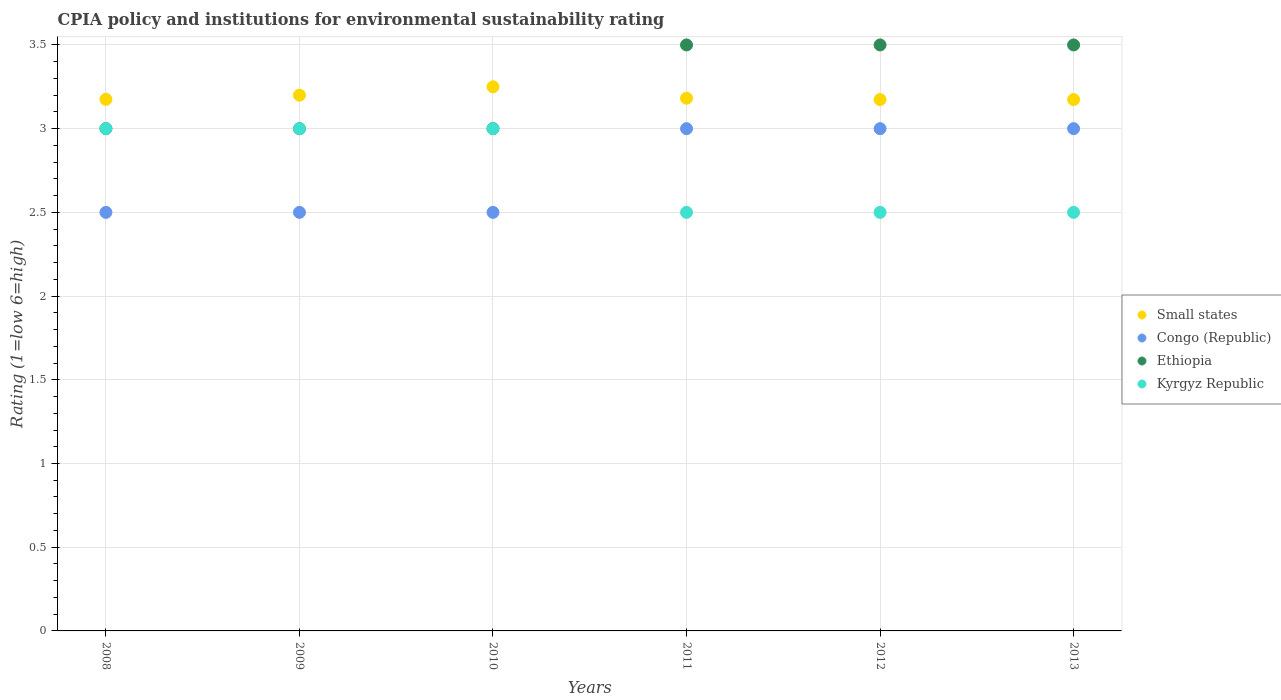Across all years, what is the minimum CPIA rating in Small states?
Your answer should be very brief. 3.17. What is the total CPIA rating in Congo (Republic) in the graph?
Offer a very short reply. 16.5. What is the difference between the CPIA rating in Small states in 2009 and that in 2011?
Offer a very short reply. 0.02. What is the difference between the CPIA rating in Small states in 2010 and the CPIA rating in Congo (Republic) in 2008?
Keep it short and to the point. 0.75. What is the average CPIA rating in Ethiopia per year?
Your answer should be compact. 3.25. In how many years, is the CPIA rating in Ethiopia greater than 2.5?
Make the answer very short. 6. Is the CPIA rating in Ethiopia in 2009 less than that in 2013?
Offer a very short reply. Yes. Is it the case that in every year, the sum of the CPIA rating in Small states and CPIA rating in Kyrgyz Republic  is greater than the sum of CPIA rating in Ethiopia and CPIA rating in Congo (Republic)?
Your answer should be very brief. No. Is it the case that in every year, the sum of the CPIA rating in Small states and CPIA rating in Congo (Republic)  is greater than the CPIA rating in Ethiopia?
Your answer should be very brief. Yes. Does the CPIA rating in Kyrgyz Republic monotonically increase over the years?
Your answer should be compact. No. Is the CPIA rating in Ethiopia strictly greater than the CPIA rating in Small states over the years?
Offer a terse response. No. How many dotlines are there?
Offer a very short reply. 4. Are the values on the major ticks of Y-axis written in scientific E-notation?
Your answer should be very brief. No. Does the graph contain any zero values?
Make the answer very short. No. How many legend labels are there?
Give a very brief answer. 4. How are the legend labels stacked?
Give a very brief answer. Vertical. What is the title of the graph?
Your response must be concise. CPIA policy and institutions for environmental sustainability rating. What is the label or title of the Y-axis?
Your response must be concise. Rating (1=low 6=high). What is the Rating (1=low 6=high) of Small states in 2008?
Your answer should be compact. 3.17. What is the Rating (1=low 6=high) in Congo (Republic) in 2008?
Make the answer very short. 2.5. What is the Rating (1=low 6=high) in Kyrgyz Republic in 2008?
Give a very brief answer. 3. What is the Rating (1=low 6=high) of Small states in 2009?
Your answer should be very brief. 3.2. What is the Rating (1=low 6=high) in Congo (Republic) in 2009?
Your answer should be very brief. 2.5. What is the Rating (1=low 6=high) in Ethiopia in 2009?
Keep it short and to the point. 3. What is the Rating (1=low 6=high) of Congo (Republic) in 2010?
Offer a terse response. 2.5. What is the Rating (1=low 6=high) in Small states in 2011?
Your response must be concise. 3.18. What is the Rating (1=low 6=high) in Ethiopia in 2011?
Your answer should be compact. 3.5. What is the Rating (1=low 6=high) in Small states in 2012?
Keep it short and to the point. 3.17. What is the Rating (1=low 6=high) in Small states in 2013?
Provide a short and direct response. 3.17. What is the Rating (1=low 6=high) of Congo (Republic) in 2013?
Ensure brevity in your answer.  3. What is the Rating (1=low 6=high) in Ethiopia in 2013?
Give a very brief answer. 3.5. What is the Rating (1=low 6=high) of Kyrgyz Republic in 2013?
Your answer should be compact. 2.5. Across all years, what is the maximum Rating (1=low 6=high) in Small states?
Offer a very short reply. 3.25. Across all years, what is the maximum Rating (1=low 6=high) in Congo (Republic)?
Offer a terse response. 3. Across all years, what is the maximum Rating (1=low 6=high) in Ethiopia?
Keep it short and to the point. 3.5. Across all years, what is the minimum Rating (1=low 6=high) of Small states?
Keep it short and to the point. 3.17. Across all years, what is the minimum Rating (1=low 6=high) of Congo (Republic)?
Ensure brevity in your answer.  2.5. Across all years, what is the minimum Rating (1=low 6=high) of Ethiopia?
Give a very brief answer. 3. Across all years, what is the minimum Rating (1=low 6=high) in Kyrgyz Republic?
Ensure brevity in your answer.  2.5. What is the total Rating (1=low 6=high) in Small states in the graph?
Offer a very short reply. 19.15. What is the difference between the Rating (1=low 6=high) in Small states in 2008 and that in 2009?
Keep it short and to the point. -0.03. What is the difference between the Rating (1=low 6=high) of Ethiopia in 2008 and that in 2009?
Your answer should be very brief. 0. What is the difference between the Rating (1=low 6=high) of Kyrgyz Republic in 2008 and that in 2009?
Give a very brief answer. 0. What is the difference between the Rating (1=low 6=high) of Small states in 2008 and that in 2010?
Provide a short and direct response. -0.07. What is the difference between the Rating (1=low 6=high) in Congo (Republic) in 2008 and that in 2010?
Your answer should be very brief. 0. What is the difference between the Rating (1=low 6=high) in Ethiopia in 2008 and that in 2010?
Provide a succinct answer. 0. What is the difference between the Rating (1=low 6=high) of Kyrgyz Republic in 2008 and that in 2010?
Make the answer very short. 0. What is the difference between the Rating (1=low 6=high) of Small states in 2008 and that in 2011?
Make the answer very short. -0.01. What is the difference between the Rating (1=low 6=high) of Kyrgyz Republic in 2008 and that in 2011?
Offer a very short reply. 0.5. What is the difference between the Rating (1=low 6=high) in Small states in 2008 and that in 2012?
Provide a succinct answer. 0. What is the difference between the Rating (1=low 6=high) in Congo (Republic) in 2008 and that in 2012?
Offer a very short reply. -0.5. What is the difference between the Rating (1=low 6=high) in Ethiopia in 2008 and that in 2012?
Provide a succinct answer. -0.5. What is the difference between the Rating (1=low 6=high) in Small states in 2008 and that in 2013?
Provide a succinct answer. 0. What is the difference between the Rating (1=low 6=high) of Kyrgyz Republic in 2009 and that in 2010?
Offer a very short reply. 0. What is the difference between the Rating (1=low 6=high) in Small states in 2009 and that in 2011?
Your answer should be very brief. 0.02. What is the difference between the Rating (1=low 6=high) in Ethiopia in 2009 and that in 2011?
Your response must be concise. -0.5. What is the difference between the Rating (1=low 6=high) in Kyrgyz Republic in 2009 and that in 2011?
Provide a short and direct response. 0.5. What is the difference between the Rating (1=low 6=high) in Small states in 2009 and that in 2012?
Provide a short and direct response. 0.03. What is the difference between the Rating (1=low 6=high) of Congo (Republic) in 2009 and that in 2012?
Your answer should be compact. -0.5. What is the difference between the Rating (1=low 6=high) in Kyrgyz Republic in 2009 and that in 2012?
Your answer should be compact. 0.5. What is the difference between the Rating (1=low 6=high) of Small states in 2009 and that in 2013?
Your response must be concise. 0.03. What is the difference between the Rating (1=low 6=high) of Congo (Republic) in 2009 and that in 2013?
Your response must be concise. -0.5. What is the difference between the Rating (1=low 6=high) of Kyrgyz Republic in 2009 and that in 2013?
Offer a very short reply. 0.5. What is the difference between the Rating (1=low 6=high) of Small states in 2010 and that in 2011?
Give a very brief answer. 0.07. What is the difference between the Rating (1=low 6=high) in Ethiopia in 2010 and that in 2011?
Offer a very short reply. -0.5. What is the difference between the Rating (1=low 6=high) in Kyrgyz Republic in 2010 and that in 2011?
Ensure brevity in your answer.  0.5. What is the difference between the Rating (1=low 6=high) of Small states in 2010 and that in 2012?
Make the answer very short. 0.08. What is the difference between the Rating (1=low 6=high) of Ethiopia in 2010 and that in 2012?
Offer a terse response. -0.5. What is the difference between the Rating (1=low 6=high) in Kyrgyz Republic in 2010 and that in 2012?
Offer a terse response. 0.5. What is the difference between the Rating (1=low 6=high) of Small states in 2010 and that in 2013?
Your response must be concise. 0.08. What is the difference between the Rating (1=low 6=high) in Congo (Republic) in 2010 and that in 2013?
Keep it short and to the point. -0.5. What is the difference between the Rating (1=low 6=high) of Ethiopia in 2010 and that in 2013?
Provide a succinct answer. -0.5. What is the difference between the Rating (1=low 6=high) in Small states in 2011 and that in 2012?
Offer a very short reply. 0.01. What is the difference between the Rating (1=low 6=high) of Small states in 2011 and that in 2013?
Make the answer very short. 0.01. What is the difference between the Rating (1=low 6=high) of Ethiopia in 2011 and that in 2013?
Your response must be concise. 0. What is the difference between the Rating (1=low 6=high) of Small states in 2012 and that in 2013?
Your response must be concise. 0. What is the difference between the Rating (1=low 6=high) of Kyrgyz Republic in 2012 and that in 2013?
Your answer should be compact. 0. What is the difference between the Rating (1=low 6=high) in Small states in 2008 and the Rating (1=low 6=high) in Congo (Republic) in 2009?
Provide a succinct answer. 0.68. What is the difference between the Rating (1=low 6=high) in Small states in 2008 and the Rating (1=low 6=high) in Ethiopia in 2009?
Your response must be concise. 0.17. What is the difference between the Rating (1=low 6=high) in Small states in 2008 and the Rating (1=low 6=high) in Kyrgyz Republic in 2009?
Ensure brevity in your answer.  0.17. What is the difference between the Rating (1=low 6=high) in Congo (Republic) in 2008 and the Rating (1=low 6=high) in Ethiopia in 2009?
Your answer should be very brief. -0.5. What is the difference between the Rating (1=low 6=high) of Ethiopia in 2008 and the Rating (1=low 6=high) of Kyrgyz Republic in 2009?
Your response must be concise. 0. What is the difference between the Rating (1=low 6=high) in Small states in 2008 and the Rating (1=low 6=high) in Congo (Republic) in 2010?
Offer a very short reply. 0.68. What is the difference between the Rating (1=low 6=high) in Small states in 2008 and the Rating (1=low 6=high) in Ethiopia in 2010?
Make the answer very short. 0.17. What is the difference between the Rating (1=low 6=high) of Small states in 2008 and the Rating (1=low 6=high) of Kyrgyz Republic in 2010?
Provide a short and direct response. 0.17. What is the difference between the Rating (1=low 6=high) of Congo (Republic) in 2008 and the Rating (1=low 6=high) of Kyrgyz Republic in 2010?
Offer a very short reply. -0.5. What is the difference between the Rating (1=low 6=high) of Ethiopia in 2008 and the Rating (1=low 6=high) of Kyrgyz Republic in 2010?
Your answer should be very brief. 0. What is the difference between the Rating (1=low 6=high) of Small states in 2008 and the Rating (1=low 6=high) of Congo (Republic) in 2011?
Provide a succinct answer. 0.17. What is the difference between the Rating (1=low 6=high) of Small states in 2008 and the Rating (1=low 6=high) of Ethiopia in 2011?
Give a very brief answer. -0.33. What is the difference between the Rating (1=low 6=high) in Small states in 2008 and the Rating (1=low 6=high) in Kyrgyz Republic in 2011?
Give a very brief answer. 0.68. What is the difference between the Rating (1=low 6=high) of Ethiopia in 2008 and the Rating (1=low 6=high) of Kyrgyz Republic in 2011?
Keep it short and to the point. 0.5. What is the difference between the Rating (1=low 6=high) in Small states in 2008 and the Rating (1=low 6=high) in Congo (Republic) in 2012?
Your answer should be very brief. 0.17. What is the difference between the Rating (1=low 6=high) of Small states in 2008 and the Rating (1=low 6=high) of Ethiopia in 2012?
Your response must be concise. -0.33. What is the difference between the Rating (1=low 6=high) of Small states in 2008 and the Rating (1=low 6=high) of Kyrgyz Republic in 2012?
Ensure brevity in your answer.  0.68. What is the difference between the Rating (1=low 6=high) of Congo (Republic) in 2008 and the Rating (1=low 6=high) of Ethiopia in 2012?
Make the answer very short. -1. What is the difference between the Rating (1=low 6=high) in Small states in 2008 and the Rating (1=low 6=high) in Congo (Republic) in 2013?
Your response must be concise. 0.17. What is the difference between the Rating (1=low 6=high) in Small states in 2008 and the Rating (1=low 6=high) in Ethiopia in 2013?
Give a very brief answer. -0.33. What is the difference between the Rating (1=low 6=high) in Small states in 2008 and the Rating (1=low 6=high) in Kyrgyz Republic in 2013?
Offer a terse response. 0.68. What is the difference between the Rating (1=low 6=high) in Congo (Republic) in 2008 and the Rating (1=low 6=high) in Kyrgyz Republic in 2013?
Provide a succinct answer. 0. What is the difference between the Rating (1=low 6=high) of Ethiopia in 2008 and the Rating (1=low 6=high) of Kyrgyz Republic in 2013?
Your answer should be compact. 0.5. What is the difference between the Rating (1=low 6=high) of Small states in 2009 and the Rating (1=low 6=high) of Ethiopia in 2010?
Provide a short and direct response. 0.2. What is the difference between the Rating (1=low 6=high) of Congo (Republic) in 2009 and the Rating (1=low 6=high) of Ethiopia in 2010?
Offer a terse response. -0.5. What is the difference between the Rating (1=low 6=high) of Congo (Republic) in 2009 and the Rating (1=low 6=high) of Ethiopia in 2011?
Provide a succinct answer. -1. What is the difference between the Rating (1=low 6=high) in Ethiopia in 2009 and the Rating (1=low 6=high) in Kyrgyz Republic in 2011?
Keep it short and to the point. 0.5. What is the difference between the Rating (1=low 6=high) of Small states in 2009 and the Rating (1=low 6=high) of Kyrgyz Republic in 2012?
Ensure brevity in your answer.  0.7. What is the difference between the Rating (1=low 6=high) of Congo (Republic) in 2009 and the Rating (1=low 6=high) of Ethiopia in 2012?
Provide a succinct answer. -1. What is the difference between the Rating (1=low 6=high) of Congo (Republic) in 2009 and the Rating (1=low 6=high) of Kyrgyz Republic in 2012?
Your answer should be compact. 0. What is the difference between the Rating (1=low 6=high) in Ethiopia in 2009 and the Rating (1=low 6=high) in Kyrgyz Republic in 2012?
Provide a short and direct response. 0.5. What is the difference between the Rating (1=low 6=high) of Small states in 2009 and the Rating (1=low 6=high) of Kyrgyz Republic in 2013?
Keep it short and to the point. 0.7. What is the difference between the Rating (1=low 6=high) in Congo (Republic) in 2009 and the Rating (1=low 6=high) in Ethiopia in 2013?
Provide a succinct answer. -1. What is the difference between the Rating (1=low 6=high) of Congo (Republic) in 2009 and the Rating (1=low 6=high) of Kyrgyz Republic in 2013?
Ensure brevity in your answer.  0. What is the difference between the Rating (1=low 6=high) of Congo (Republic) in 2010 and the Rating (1=low 6=high) of Ethiopia in 2011?
Give a very brief answer. -1. What is the difference between the Rating (1=low 6=high) in Congo (Republic) in 2010 and the Rating (1=low 6=high) in Kyrgyz Republic in 2012?
Provide a short and direct response. 0. What is the difference between the Rating (1=low 6=high) in Ethiopia in 2010 and the Rating (1=low 6=high) in Kyrgyz Republic in 2012?
Your answer should be very brief. 0.5. What is the difference between the Rating (1=low 6=high) in Small states in 2010 and the Rating (1=low 6=high) in Congo (Republic) in 2013?
Offer a very short reply. 0.25. What is the difference between the Rating (1=low 6=high) in Small states in 2010 and the Rating (1=low 6=high) in Ethiopia in 2013?
Your answer should be compact. -0.25. What is the difference between the Rating (1=low 6=high) of Small states in 2010 and the Rating (1=low 6=high) of Kyrgyz Republic in 2013?
Your answer should be very brief. 0.75. What is the difference between the Rating (1=low 6=high) of Congo (Republic) in 2010 and the Rating (1=low 6=high) of Ethiopia in 2013?
Offer a terse response. -1. What is the difference between the Rating (1=low 6=high) of Ethiopia in 2010 and the Rating (1=low 6=high) of Kyrgyz Republic in 2013?
Give a very brief answer. 0.5. What is the difference between the Rating (1=low 6=high) in Small states in 2011 and the Rating (1=low 6=high) in Congo (Republic) in 2012?
Your answer should be compact. 0.18. What is the difference between the Rating (1=low 6=high) of Small states in 2011 and the Rating (1=low 6=high) of Ethiopia in 2012?
Ensure brevity in your answer.  -0.32. What is the difference between the Rating (1=low 6=high) in Small states in 2011 and the Rating (1=low 6=high) in Kyrgyz Republic in 2012?
Your response must be concise. 0.68. What is the difference between the Rating (1=low 6=high) in Congo (Republic) in 2011 and the Rating (1=low 6=high) in Kyrgyz Republic in 2012?
Your answer should be very brief. 0.5. What is the difference between the Rating (1=low 6=high) in Small states in 2011 and the Rating (1=low 6=high) in Congo (Republic) in 2013?
Ensure brevity in your answer.  0.18. What is the difference between the Rating (1=low 6=high) in Small states in 2011 and the Rating (1=low 6=high) in Ethiopia in 2013?
Provide a succinct answer. -0.32. What is the difference between the Rating (1=low 6=high) in Small states in 2011 and the Rating (1=low 6=high) in Kyrgyz Republic in 2013?
Offer a very short reply. 0.68. What is the difference between the Rating (1=low 6=high) in Small states in 2012 and the Rating (1=low 6=high) in Congo (Republic) in 2013?
Your response must be concise. 0.17. What is the difference between the Rating (1=low 6=high) of Small states in 2012 and the Rating (1=low 6=high) of Ethiopia in 2013?
Offer a terse response. -0.33. What is the difference between the Rating (1=low 6=high) in Small states in 2012 and the Rating (1=low 6=high) in Kyrgyz Republic in 2013?
Keep it short and to the point. 0.67. What is the difference between the Rating (1=low 6=high) in Congo (Republic) in 2012 and the Rating (1=low 6=high) in Ethiopia in 2013?
Offer a very short reply. -0.5. What is the difference between the Rating (1=low 6=high) in Congo (Republic) in 2012 and the Rating (1=low 6=high) in Kyrgyz Republic in 2013?
Provide a short and direct response. 0.5. What is the average Rating (1=low 6=high) in Small states per year?
Make the answer very short. 3.19. What is the average Rating (1=low 6=high) of Congo (Republic) per year?
Your answer should be compact. 2.75. What is the average Rating (1=low 6=high) of Ethiopia per year?
Keep it short and to the point. 3.25. What is the average Rating (1=low 6=high) of Kyrgyz Republic per year?
Offer a terse response. 2.75. In the year 2008, what is the difference between the Rating (1=low 6=high) in Small states and Rating (1=low 6=high) in Congo (Republic)?
Ensure brevity in your answer.  0.68. In the year 2008, what is the difference between the Rating (1=low 6=high) in Small states and Rating (1=low 6=high) in Ethiopia?
Ensure brevity in your answer.  0.17. In the year 2008, what is the difference between the Rating (1=low 6=high) of Small states and Rating (1=low 6=high) of Kyrgyz Republic?
Ensure brevity in your answer.  0.17. In the year 2008, what is the difference between the Rating (1=low 6=high) of Congo (Republic) and Rating (1=low 6=high) of Ethiopia?
Your answer should be very brief. -0.5. In the year 2008, what is the difference between the Rating (1=low 6=high) of Congo (Republic) and Rating (1=low 6=high) of Kyrgyz Republic?
Your response must be concise. -0.5. In the year 2009, what is the difference between the Rating (1=low 6=high) of Small states and Rating (1=low 6=high) of Ethiopia?
Ensure brevity in your answer.  0.2. In the year 2009, what is the difference between the Rating (1=low 6=high) of Congo (Republic) and Rating (1=low 6=high) of Ethiopia?
Ensure brevity in your answer.  -0.5. In the year 2009, what is the difference between the Rating (1=low 6=high) of Congo (Republic) and Rating (1=low 6=high) of Kyrgyz Republic?
Your answer should be very brief. -0.5. In the year 2010, what is the difference between the Rating (1=low 6=high) of Small states and Rating (1=low 6=high) of Congo (Republic)?
Your response must be concise. 0.75. In the year 2010, what is the difference between the Rating (1=low 6=high) in Small states and Rating (1=low 6=high) in Ethiopia?
Ensure brevity in your answer.  0.25. In the year 2010, what is the difference between the Rating (1=low 6=high) in Small states and Rating (1=low 6=high) in Kyrgyz Republic?
Offer a very short reply. 0.25. In the year 2010, what is the difference between the Rating (1=low 6=high) of Congo (Republic) and Rating (1=low 6=high) of Kyrgyz Republic?
Provide a short and direct response. -0.5. In the year 2010, what is the difference between the Rating (1=low 6=high) in Ethiopia and Rating (1=low 6=high) in Kyrgyz Republic?
Provide a succinct answer. 0. In the year 2011, what is the difference between the Rating (1=low 6=high) in Small states and Rating (1=low 6=high) in Congo (Republic)?
Your response must be concise. 0.18. In the year 2011, what is the difference between the Rating (1=low 6=high) in Small states and Rating (1=low 6=high) in Ethiopia?
Make the answer very short. -0.32. In the year 2011, what is the difference between the Rating (1=low 6=high) of Small states and Rating (1=low 6=high) of Kyrgyz Republic?
Provide a short and direct response. 0.68. In the year 2011, what is the difference between the Rating (1=low 6=high) of Congo (Republic) and Rating (1=low 6=high) of Ethiopia?
Your answer should be very brief. -0.5. In the year 2011, what is the difference between the Rating (1=low 6=high) of Congo (Republic) and Rating (1=low 6=high) of Kyrgyz Republic?
Your response must be concise. 0.5. In the year 2012, what is the difference between the Rating (1=low 6=high) in Small states and Rating (1=low 6=high) in Congo (Republic)?
Keep it short and to the point. 0.17. In the year 2012, what is the difference between the Rating (1=low 6=high) of Small states and Rating (1=low 6=high) of Ethiopia?
Provide a succinct answer. -0.33. In the year 2012, what is the difference between the Rating (1=low 6=high) in Small states and Rating (1=low 6=high) in Kyrgyz Republic?
Give a very brief answer. 0.67. In the year 2012, what is the difference between the Rating (1=low 6=high) in Congo (Republic) and Rating (1=low 6=high) in Ethiopia?
Offer a very short reply. -0.5. In the year 2012, what is the difference between the Rating (1=low 6=high) of Congo (Republic) and Rating (1=low 6=high) of Kyrgyz Republic?
Keep it short and to the point. 0.5. In the year 2012, what is the difference between the Rating (1=low 6=high) of Ethiopia and Rating (1=low 6=high) of Kyrgyz Republic?
Provide a short and direct response. 1. In the year 2013, what is the difference between the Rating (1=low 6=high) in Small states and Rating (1=low 6=high) in Congo (Republic)?
Your response must be concise. 0.17. In the year 2013, what is the difference between the Rating (1=low 6=high) in Small states and Rating (1=low 6=high) in Ethiopia?
Provide a succinct answer. -0.33. In the year 2013, what is the difference between the Rating (1=low 6=high) of Small states and Rating (1=low 6=high) of Kyrgyz Republic?
Give a very brief answer. 0.67. In the year 2013, what is the difference between the Rating (1=low 6=high) of Congo (Republic) and Rating (1=low 6=high) of Ethiopia?
Your answer should be very brief. -0.5. In the year 2013, what is the difference between the Rating (1=low 6=high) of Ethiopia and Rating (1=low 6=high) of Kyrgyz Republic?
Your answer should be very brief. 1. What is the ratio of the Rating (1=low 6=high) of Small states in 2008 to that in 2009?
Ensure brevity in your answer.  0.99. What is the ratio of the Rating (1=low 6=high) of Ethiopia in 2008 to that in 2009?
Provide a succinct answer. 1. What is the ratio of the Rating (1=low 6=high) of Kyrgyz Republic in 2008 to that in 2009?
Give a very brief answer. 1. What is the ratio of the Rating (1=low 6=high) in Small states in 2008 to that in 2010?
Your response must be concise. 0.98. What is the ratio of the Rating (1=low 6=high) in Congo (Republic) in 2008 to that in 2010?
Keep it short and to the point. 1. What is the ratio of the Rating (1=low 6=high) of Ethiopia in 2008 to that in 2010?
Your answer should be very brief. 1. What is the ratio of the Rating (1=low 6=high) in Small states in 2008 to that in 2011?
Your response must be concise. 1. What is the ratio of the Rating (1=low 6=high) of Congo (Republic) in 2008 to that in 2011?
Your answer should be compact. 0.83. What is the ratio of the Rating (1=low 6=high) in Small states in 2008 to that in 2012?
Ensure brevity in your answer.  1. What is the ratio of the Rating (1=low 6=high) in Kyrgyz Republic in 2008 to that in 2012?
Offer a very short reply. 1.2. What is the ratio of the Rating (1=low 6=high) of Congo (Republic) in 2008 to that in 2013?
Your answer should be very brief. 0.83. What is the ratio of the Rating (1=low 6=high) of Ethiopia in 2008 to that in 2013?
Provide a succinct answer. 0.86. What is the ratio of the Rating (1=low 6=high) in Small states in 2009 to that in 2010?
Ensure brevity in your answer.  0.98. What is the ratio of the Rating (1=low 6=high) of Congo (Republic) in 2009 to that in 2010?
Keep it short and to the point. 1. What is the ratio of the Rating (1=low 6=high) in Ethiopia in 2009 to that in 2010?
Offer a terse response. 1. What is the ratio of the Rating (1=low 6=high) of Kyrgyz Republic in 2009 to that in 2010?
Your answer should be very brief. 1. What is the ratio of the Rating (1=low 6=high) in Small states in 2009 to that in 2011?
Provide a short and direct response. 1.01. What is the ratio of the Rating (1=low 6=high) in Congo (Republic) in 2009 to that in 2011?
Your answer should be compact. 0.83. What is the ratio of the Rating (1=low 6=high) in Ethiopia in 2009 to that in 2011?
Provide a short and direct response. 0.86. What is the ratio of the Rating (1=low 6=high) in Small states in 2009 to that in 2012?
Your answer should be very brief. 1.01. What is the ratio of the Rating (1=low 6=high) in Ethiopia in 2009 to that in 2012?
Your answer should be compact. 0.86. What is the ratio of the Rating (1=low 6=high) of Small states in 2009 to that in 2013?
Provide a short and direct response. 1.01. What is the ratio of the Rating (1=low 6=high) in Congo (Republic) in 2009 to that in 2013?
Make the answer very short. 0.83. What is the ratio of the Rating (1=low 6=high) in Small states in 2010 to that in 2011?
Provide a succinct answer. 1.02. What is the ratio of the Rating (1=low 6=high) in Congo (Republic) in 2010 to that in 2011?
Provide a short and direct response. 0.83. What is the ratio of the Rating (1=low 6=high) of Ethiopia in 2010 to that in 2011?
Your response must be concise. 0.86. What is the ratio of the Rating (1=low 6=high) in Kyrgyz Republic in 2010 to that in 2011?
Provide a succinct answer. 1.2. What is the ratio of the Rating (1=low 6=high) in Small states in 2010 to that in 2012?
Offer a terse response. 1.02. What is the ratio of the Rating (1=low 6=high) of Congo (Republic) in 2010 to that in 2012?
Your answer should be very brief. 0.83. What is the ratio of the Rating (1=low 6=high) of Ethiopia in 2010 to that in 2012?
Your answer should be very brief. 0.86. What is the ratio of the Rating (1=low 6=high) of Kyrgyz Republic in 2010 to that in 2012?
Make the answer very short. 1.2. What is the ratio of the Rating (1=low 6=high) in Congo (Republic) in 2010 to that in 2013?
Give a very brief answer. 0.83. What is the ratio of the Rating (1=low 6=high) of Small states in 2011 to that in 2012?
Offer a very short reply. 1. What is the ratio of the Rating (1=low 6=high) in Congo (Republic) in 2011 to that in 2012?
Ensure brevity in your answer.  1. What is the ratio of the Rating (1=low 6=high) of Kyrgyz Republic in 2011 to that in 2012?
Your answer should be compact. 1. What is the ratio of the Rating (1=low 6=high) of Ethiopia in 2011 to that in 2013?
Provide a short and direct response. 1. What is the ratio of the Rating (1=low 6=high) in Kyrgyz Republic in 2011 to that in 2013?
Keep it short and to the point. 1. What is the ratio of the Rating (1=low 6=high) in Kyrgyz Republic in 2012 to that in 2013?
Your response must be concise. 1. What is the difference between the highest and the second highest Rating (1=low 6=high) in Congo (Republic)?
Ensure brevity in your answer.  0. What is the difference between the highest and the second highest Rating (1=low 6=high) in Ethiopia?
Your response must be concise. 0. What is the difference between the highest and the lowest Rating (1=low 6=high) in Small states?
Ensure brevity in your answer.  0.08. What is the difference between the highest and the lowest Rating (1=low 6=high) of Congo (Republic)?
Provide a short and direct response. 0.5. 